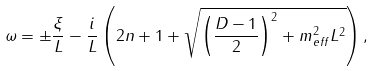<formula> <loc_0><loc_0><loc_500><loc_500>\omega = \pm \frac { \xi } { L } - \frac { i } { L } \left ( 2 n + 1 + \sqrt { \left ( \frac { D - 1 } { 2 } \right ) ^ { 2 } + m _ { e f f } ^ { 2 } L ^ { 2 } } \right ) ,</formula> 